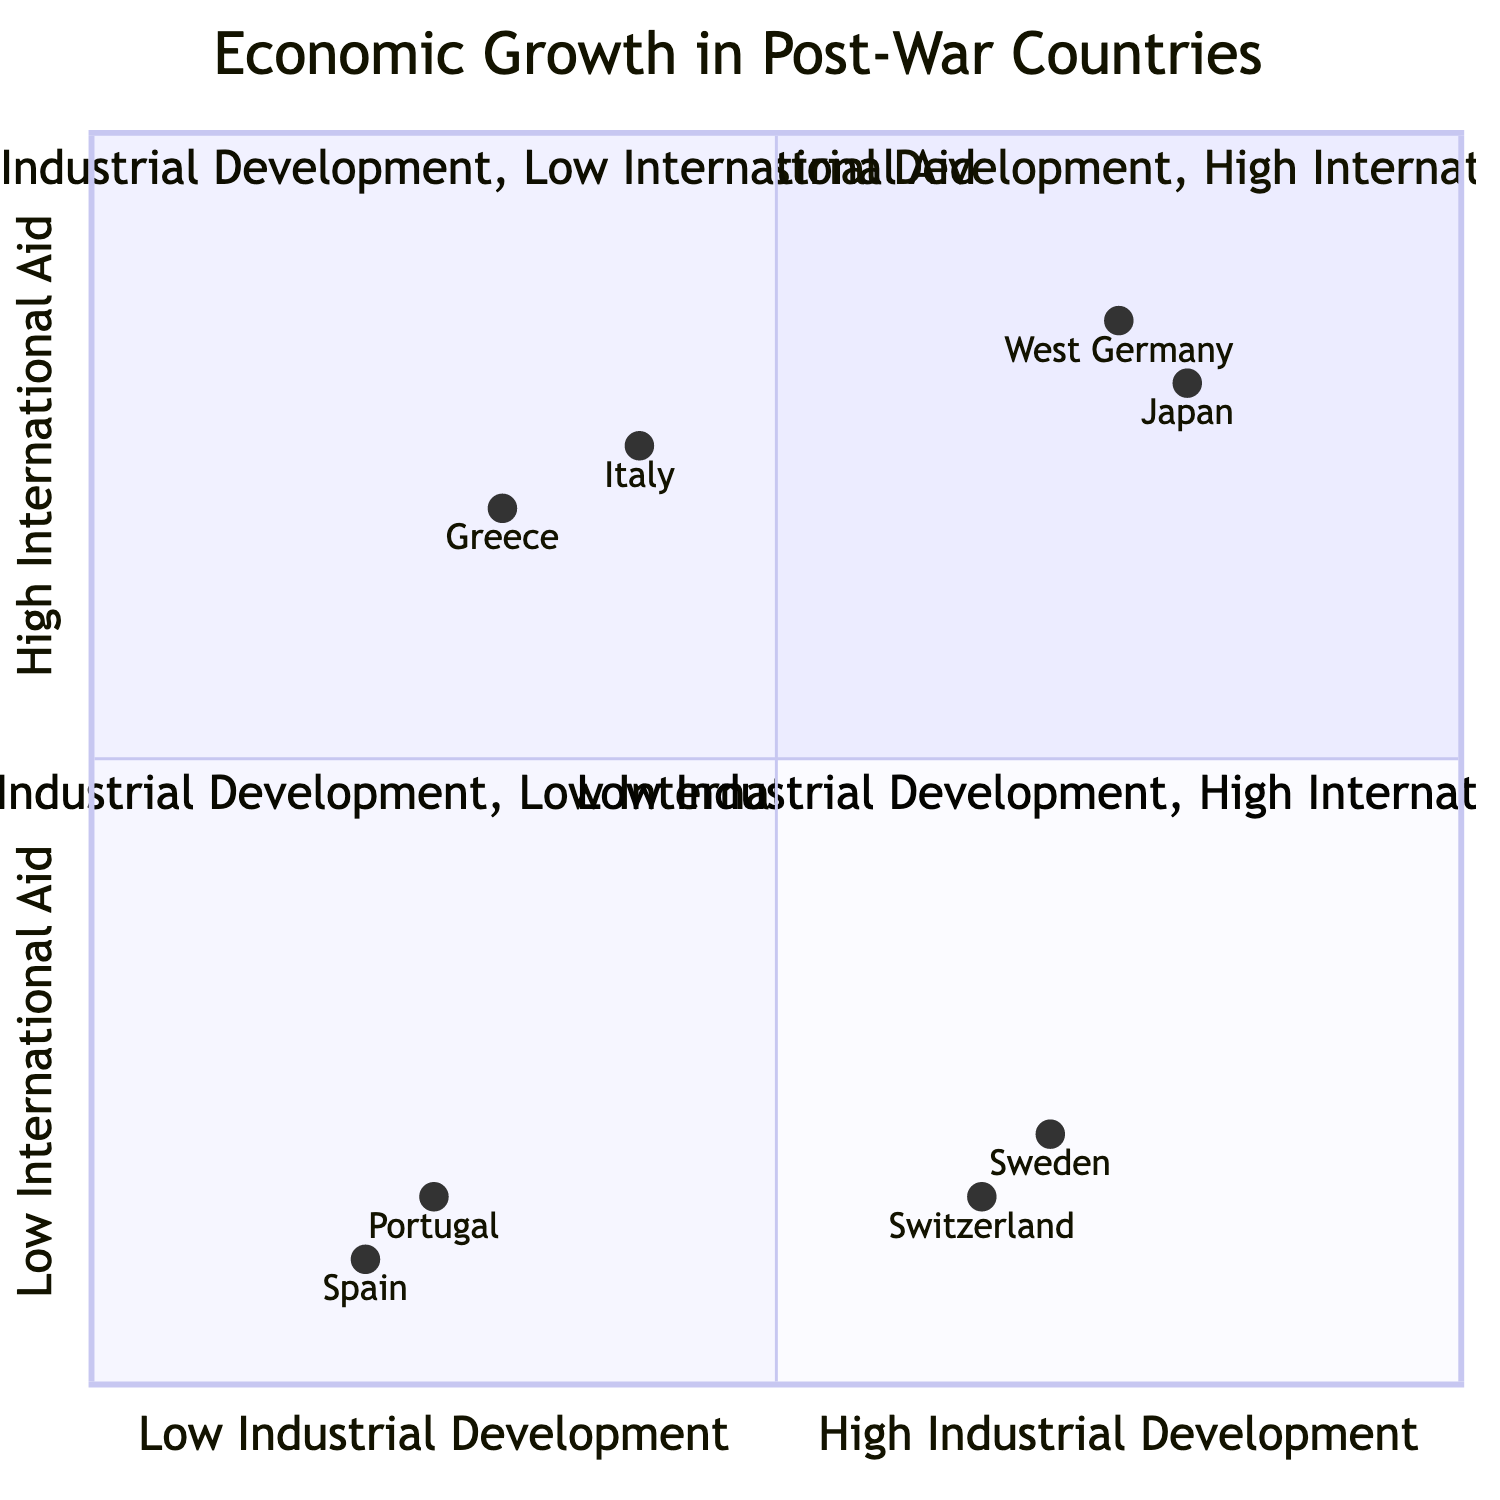What countries fall under the "High Industrial Development, High International Aid" quadrant? In the diagram, the quadrant labeled "High Industrial Development, High International Aid" includes West Germany and Japan, as they are positioned in that specific quadrant.
Answer: West Germany, Japan Which country had the highest GDP growth according to the diagram? By examining the key indicators in each quadrant, Japan shows the highest GDP growth of 9.8%, which is greater than that of any other country represented in the diagram.
Answer: 9.8% What is the industrial output growth of Greece? In the "Low Industrial Development, High International Aid" quadrant, Greece's key indicators show an industrial output growth of 3%.
Answer: 3% How many countries are in the "Low Industrial Development, Low International Aid" quadrant? The "Low Industrial Development, Low International Aid" quadrant contains Spain and Portugal, totaling two countries, as indicated by their presence in that section of the diagram.
Answer: 2 Which quadrant contains countries that received no international aid? The "High Industrial Development, Low International Aid" and "Low Industrial Development, Low International Aid" quadrants contain countries that received no international aid, as observed by their lack of specified aid programs.
Answer: High Industrial Development, Low International Aid & Low Industrial Development, Low International Aid 